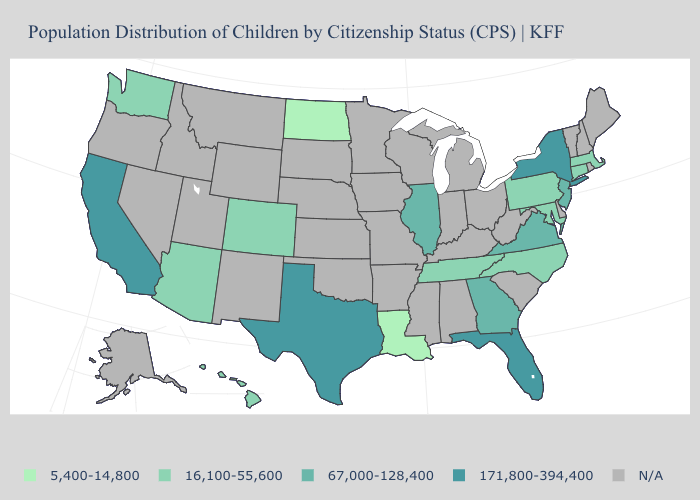Which states have the highest value in the USA?
Quick response, please. California, Florida, New York, Texas. Is the legend a continuous bar?
Answer briefly. No. What is the lowest value in the USA?
Answer briefly. 5,400-14,800. Which states have the highest value in the USA?
Answer briefly. California, Florida, New York, Texas. What is the highest value in states that border West Virginia?
Short answer required. 67,000-128,400. Is the legend a continuous bar?
Short answer required. No. Does the first symbol in the legend represent the smallest category?
Concise answer only. Yes. What is the lowest value in the USA?
Give a very brief answer. 5,400-14,800. What is the value of Oklahoma?
Short answer required. N/A. What is the highest value in the South ?
Short answer required. 171,800-394,400. Does Maryland have the highest value in the South?
Write a very short answer. No. What is the highest value in the USA?
Short answer required. 171,800-394,400. Name the states that have a value in the range 171,800-394,400?
Concise answer only. California, Florida, New York, Texas. Which states have the lowest value in the USA?
Concise answer only. Louisiana, North Dakota. What is the value of Utah?
Quick response, please. N/A. 